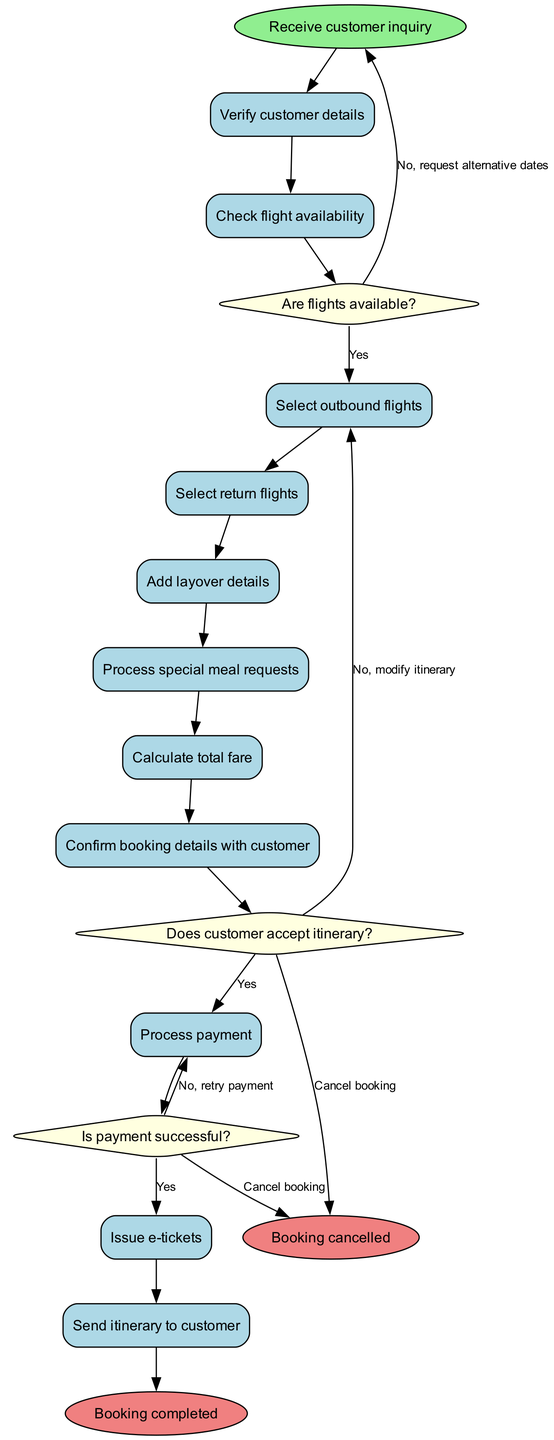What is the first activity in the diagram? The first activity is indicated immediately after the start node. It is labeled as "Verify customer details."
Answer: Verify customer details How many decision nodes are present in the diagram? There are three decision nodes shown in the diagram, each representing a question to be answered before proceeding.
Answer: 3 What happens if the customer does not accept the itinerary? The diagram shows that if the customer does not accept the itinerary, the flow leads to the "Modify itinerary" action, indicating a step to make changes.
Answer: Modify itinerary What activity follows the "Process payment"? The activity that follows "Process payment" in the flow is "Issue e-tickets," indicating the next step in the booking process.
Answer: Issue e-tickets What is the outcome if the payment is not successful? If the payment is not successful, the diagram indicates that the flow loops back to "Process payment," suggesting a retry of payment.
Answer: Retry payment How many end nodes are indicated in the diagram? The diagram has two end nodes, representing the possible outcomes of the process, either successful booking or cancellation.
Answer: 2 What is the label for the edge from the decision node regarding flight availability if flights are not available? The edge leading from the decision node for flight availability, if flights are not available, is labeled "No, request alternative dates," guiding the next action if that condition is true.
Answer: No, request alternative dates If the customer cancels the booking, what is the resulting node? According to the diagram, if the customer cancels the booking, the flow leads directly to the "Booking cancelled" end node.
Answer: Booking cancelled 